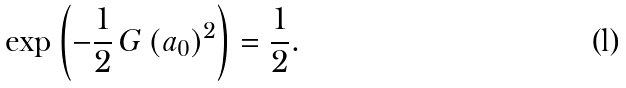Convert formula to latex. <formula><loc_0><loc_0><loc_500><loc_500>\exp \left ( - \frac { 1 } { 2 } \, G \, ( a _ { 0 } ) ^ { 2 } \right ) = \frac { 1 } { 2 } .</formula> 